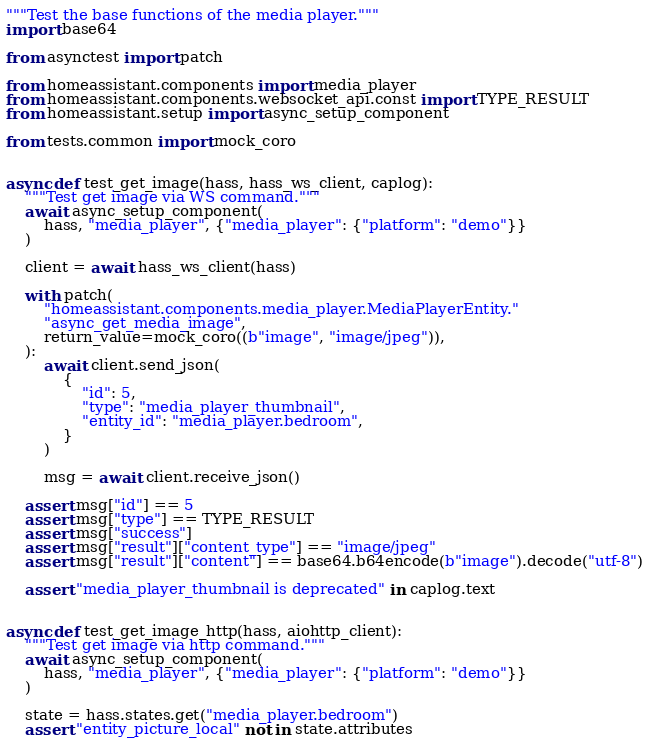Convert code to text. <code><loc_0><loc_0><loc_500><loc_500><_Python_>"""Test the base functions of the media player."""
import base64

from asynctest import patch

from homeassistant.components import media_player
from homeassistant.components.websocket_api.const import TYPE_RESULT
from homeassistant.setup import async_setup_component

from tests.common import mock_coro


async def test_get_image(hass, hass_ws_client, caplog):
    """Test get image via WS command."""
    await async_setup_component(
        hass, "media_player", {"media_player": {"platform": "demo"}}
    )

    client = await hass_ws_client(hass)

    with patch(
        "homeassistant.components.media_player.MediaPlayerEntity."
        "async_get_media_image",
        return_value=mock_coro((b"image", "image/jpeg")),
    ):
        await client.send_json(
            {
                "id": 5,
                "type": "media_player_thumbnail",
                "entity_id": "media_player.bedroom",
            }
        )

        msg = await client.receive_json()

    assert msg["id"] == 5
    assert msg["type"] == TYPE_RESULT
    assert msg["success"]
    assert msg["result"]["content_type"] == "image/jpeg"
    assert msg["result"]["content"] == base64.b64encode(b"image").decode("utf-8")

    assert "media_player_thumbnail is deprecated" in caplog.text


async def test_get_image_http(hass, aiohttp_client):
    """Test get image via http command."""
    await async_setup_component(
        hass, "media_player", {"media_player": {"platform": "demo"}}
    )

    state = hass.states.get("media_player.bedroom")
    assert "entity_picture_local" not in state.attributes
</code> 